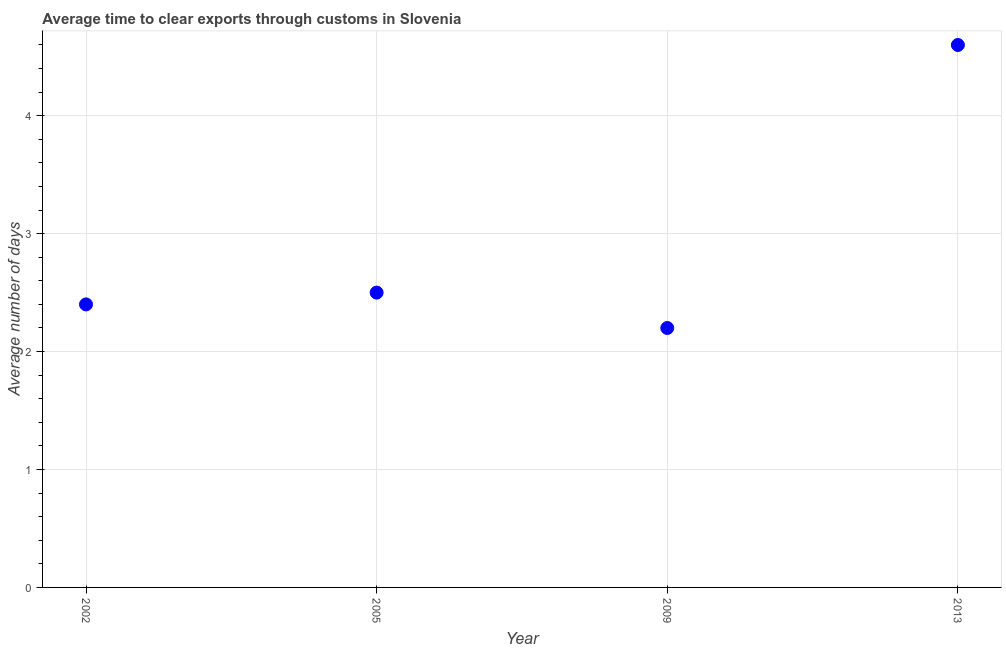What is the time to clear exports through customs in 2013?
Provide a succinct answer. 4.6. Across all years, what is the minimum time to clear exports through customs?
Your response must be concise. 2.2. In which year was the time to clear exports through customs minimum?
Provide a short and direct response. 2009. What is the difference between the time to clear exports through customs in 2002 and 2005?
Make the answer very short. -0.1. What is the average time to clear exports through customs per year?
Your answer should be compact. 2.92. What is the median time to clear exports through customs?
Ensure brevity in your answer.  2.45. In how many years, is the time to clear exports through customs greater than 2.4 days?
Your response must be concise. 2. Do a majority of the years between 2009 and 2005 (inclusive) have time to clear exports through customs greater than 1.8 days?
Your response must be concise. No. What is the ratio of the time to clear exports through customs in 2005 to that in 2009?
Your answer should be compact. 1.14. Is the time to clear exports through customs in 2009 less than that in 2013?
Keep it short and to the point. Yes. What is the difference between the highest and the second highest time to clear exports through customs?
Keep it short and to the point. 2.1. What is the difference between the highest and the lowest time to clear exports through customs?
Ensure brevity in your answer.  2.4. In how many years, is the time to clear exports through customs greater than the average time to clear exports through customs taken over all years?
Make the answer very short. 1. Does the time to clear exports through customs monotonically increase over the years?
Provide a short and direct response. No. How many dotlines are there?
Give a very brief answer. 1. What is the title of the graph?
Make the answer very short. Average time to clear exports through customs in Slovenia. What is the label or title of the X-axis?
Give a very brief answer. Year. What is the label or title of the Y-axis?
Offer a terse response. Average number of days. What is the Average number of days in 2005?
Offer a terse response. 2.5. What is the Average number of days in 2013?
Provide a succinct answer. 4.6. What is the difference between the Average number of days in 2002 and 2013?
Your answer should be compact. -2.2. What is the difference between the Average number of days in 2005 and 2013?
Provide a short and direct response. -2.1. What is the difference between the Average number of days in 2009 and 2013?
Make the answer very short. -2.4. What is the ratio of the Average number of days in 2002 to that in 2009?
Your answer should be compact. 1.09. What is the ratio of the Average number of days in 2002 to that in 2013?
Offer a terse response. 0.52. What is the ratio of the Average number of days in 2005 to that in 2009?
Offer a terse response. 1.14. What is the ratio of the Average number of days in 2005 to that in 2013?
Keep it short and to the point. 0.54. What is the ratio of the Average number of days in 2009 to that in 2013?
Ensure brevity in your answer.  0.48. 